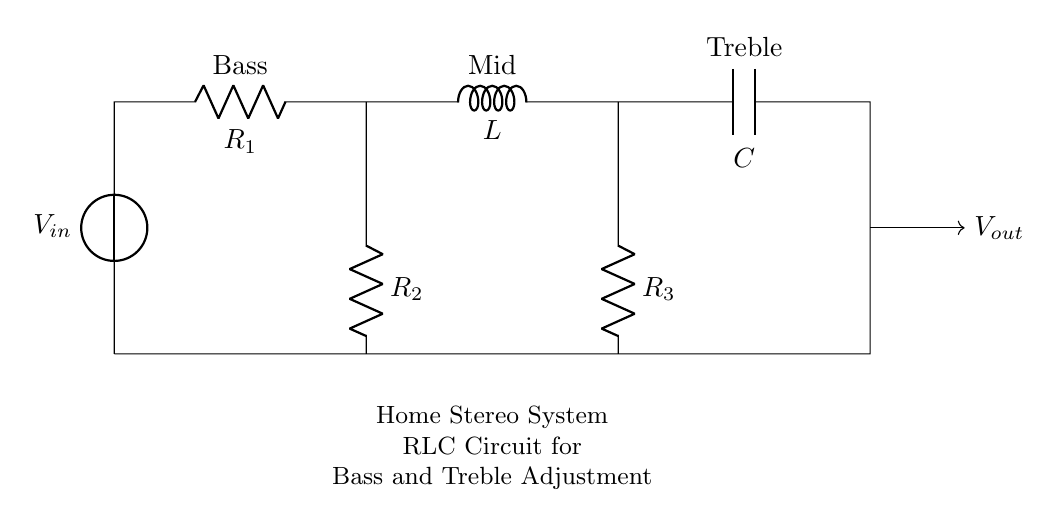What is the input voltage in the circuit? The input voltage is represented by the voltage source labeled as V_in at the top left of the circuit diagram.
Answer: V_in What component is used for treble adjustment? The capacitive component, labeled as C, is used for treble adjustment, and it's located at the end of the circuit diagram.
Answer: C How many resistors are present in the circuit? There are three resistors in the circuit, labeled as R_1, R_2, and R_3, each contributing to different frequency adjustments.
Answer: 3 What is the function of the inductor in this circuit? The inductor, labeled L, is used to control the mid frequencies, allowing for tuning in that range while affecting the overall audio quality.
Answer: Control mid frequencies What does the output voltage represent? The output voltage, represented by V_out, is the signal that comes out of the circuit after passing through the bass and treble adjustments made by the components.
Answer: V_out What is the arrangement of the resistors relative to the inductor and capacitor? The resistors are in parallel with the inductor and capacitor in this circuit, allowing for independent adjustment of frequencies.
Answer: Parallel arrangement 